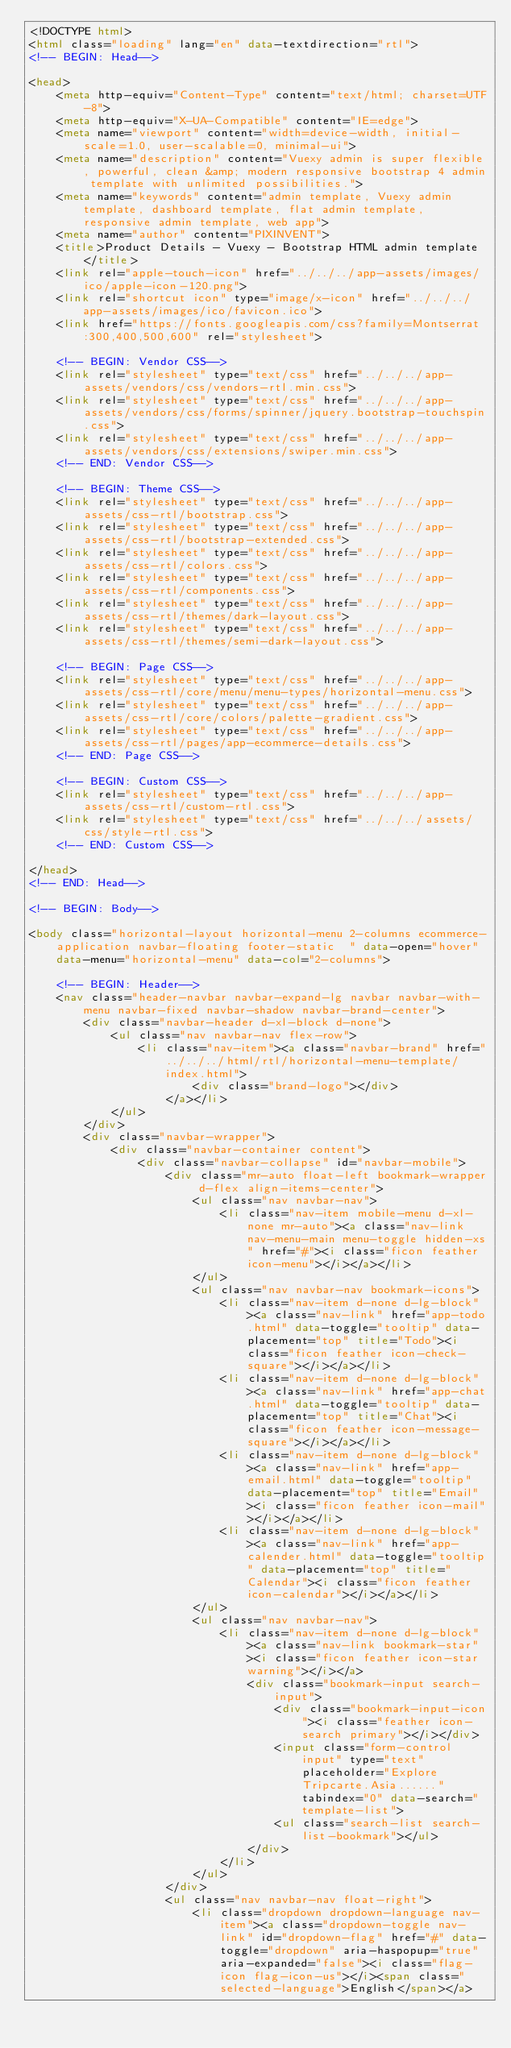<code> <loc_0><loc_0><loc_500><loc_500><_HTML_><!DOCTYPE html>
<html class="loading" lang="en" data-textdirection="rtl">
<!-- BEGIN: Head-->

<head>
    <meta http-equiv="Content-Type" content="text/html; charset=UTF-8">
    <meta http-equiv="X-UA-Compatible" content="IE=edge">
    <meta name="viewport" content="width=device-width, initial-scale=1.0, user-scalable=0, minimal-ui">
    <meta name="description" content="Vuexy admin is super flexible, powerful, clean &amp; modern responsive bootstrap 4 admin template with unlimited possibilities.">
    <meta name="keywords" content="admin template, Vuexy admin template, dashboard template, flat admin template, responsive admin template, web app">
    <meta name="author" content="PIXINVENT">
    <title>Product Details - Vuexy - Bootstrap HTML admin template</title>
    <link rel="apple-touch-icon" href="../../../app-assets/images/ico/apple-icon-120.png">
    <link rel="shortcut icon" type="image/x-icon" href="../../../app-assets/images/ico/favicon.ico">
    <link href="https://fonts.googleapis.com/css?family=Montserrat:300,400,500,600" rel="stylesheet">

    <!-- BEGIN: Vendor CSS-->
    <link rel="stylesheet" type="text/css" href="../../../app-assets/vendors/css/vendors-rtl.min.css">
    <link rel="stylesheet" type="text/css" href="../../../app-assets/vendors/css/forms/spinner/jquery.bootstrap-touchspin.css">
    <link rel="stylesheet" type="text/css" href="../../../app-assets/vendors/css/extensions/swiper.min.css">
    <!-- END: Vendor CSS-->

    <!-- BEGIN: Theme CSS-->
    <link rel="stylesheet" type="text/css" href="../../../app-assets/css-rtl/bootstrap.css">
    <link rel="stylesheet" type="text/css" href="../../../app-assets/css-rtl/bootstrap-extended.css">
    <link rel="stylesheet" type="text/css" href="../../../app-assets/css-rtl/colors.css">
    <link rel="stylesheet" type="text/css" href="../../../app-assets/css-rtl/components.css">
    <link rel="stylesheet" type="text/css" href="../../../app-assets/css-rtl/themes/dark-layout.css">
    <link rel="stylesheet" type="text/css" href="../../../app-assets/css-rtl/themes/semi-dark-layout.css">

    <!-- BEGIN: Page CSS-->
    <link rel="stylesheet" type="text/css" href="../../../app-assets/css-rtl/core/menu/menu-types/horizontal-menu.css">
    <link rel="stylesheet" type="text/css" href="../../../app-assets/css-rtl/core/colors/palette-gradient.css">
    <link rel="stylesheet" type="text/css" href="../../../app-assets/css-rtl/pages/app-ecommerce-details.css">
    <!-- END: Page CSS-->

    <!-- BEGIN: Custom CSS-->
    <link rel="stylesheet" type="text/css" href="../../../app-assets/css-rtl/custom-rtl.css">
    <link rel="stylesheet" type="text/css" href="../../../assets/css/style-rtl.css">
    <!-- END: Custom CSS-->

</head>
<!-- END: Head-->

<!-- BEGIN: Body-->

<body class="horizontal-layout horizontal-menu 2-columns ecommerce-application navbar-floating footer-static  " data-open="hover" data-menu="horizontal-menu" data-col="2-columns">

    <!-- BEGIN: Header-->
    <nav class="header-navbar navbar-expand-lg navbar navbar-with-menu navbar-fixed navbar-shadow navbar-brand-center">
        <div class="navbar-header d-xl-block d-none">
            <ul class="nav navbar-nav flex-row">
                <li class="nav-item"><a class="navbar-brand" href="../../../html/rtl/horizontal-menu-template/index.html">
                        <div class="brand-logo"></div>
                    </a></li>
            </ul>
        </div>
        <div class="navbar-wrapper">
            <div class="navbar-container content">
                <div class="navbar-collapse" id="navbar-mobile">
                    <div class="mr-auto float-left bookmark-wrapper d-flex align-items-center">
                        <ul class="nav navbar-nav">
                            <li class="nav-item mobile-menu d-xl-none mr-auto"><a class="nav-link nav-menu-main menu-toggle hidden-xs" href="#"><i class="ficon feather icon-menu"></i></a></li>
                        </ul>
                        <ul class="nav navbar-nav bookmark-icons">
                            <li class="nav-item d-none d-lg-block"><a class="nav-link" href="app-todo.html" data-toggle="tooltip" data-placement="top" title="Todo"><i class="ficon feather icon-check-square"></i></a></li>
                            <li class="nav-item d-none d-lg-block"><a class="nav-link" href="app-chat.html" data-toggle="tooltip" data-placement="top" title="Chat"><i class="ficon feather icon-message-square"></i></a></li>
                            <li class="nav-item d-none d-lg-block"><a class="nav-link" href="app-email.html" data-toggle="tooltip" data-placement="top" title="Email"><i class="ficon feather icon-mail"></i></a></li>
                            <li class="nav-item d-none d-lg-block"><a class="nav-link" href="app-calender.html" data-toggle="tooltip" data-placement="top" title="Calendar"><i class="ficon feather icon-calendar"></i></a></li>
                        </ul>
                        <ul class="nav navbar-nav">
                            <li class="nav-item d-none d-lg-block"><a class="nav-link bookmark-star"><i class="ficon feather icon-star warning"></i></a>
                                <div class="bookmark-input search-input">
                                    <div class="bookmark-input-icon"><i class="feather icon-search primary"></i></div>
                                    <input class="form-control input" type="text" placeholder="Explore Tripcarte.Asia......" tabindex="0" data-search="template-list">
                                    <ul class="search-list search-list-bookmark"></ul>
                                </div>
                            </li>
                        </ul>
                    </div>
                    <ul class="nav navbar-nav float-right">
                        <li class="dropdown dropdown-language nav-item"><a class="dropdown-toggle nav-link" id="dropdown-flag" href="#" data-toggle="dropdown" aria-haspopup="true" aria-expanded="false"><i class="flag-icon flag-icon-us"></i><span class="selected-language">English</span></a></code> 